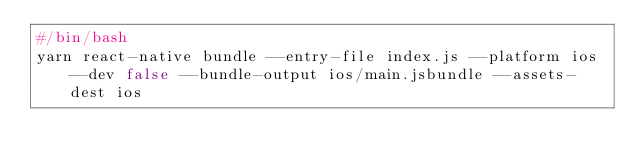<code> <loc_0><loc_0><loc_500><loc_500><_Bash_>#/bin/bash
yarn react-native bundle --entry-file index.js --platform ios --dev false --bundle-output ios/main.jsbundle --assets-dest ios

</code> 